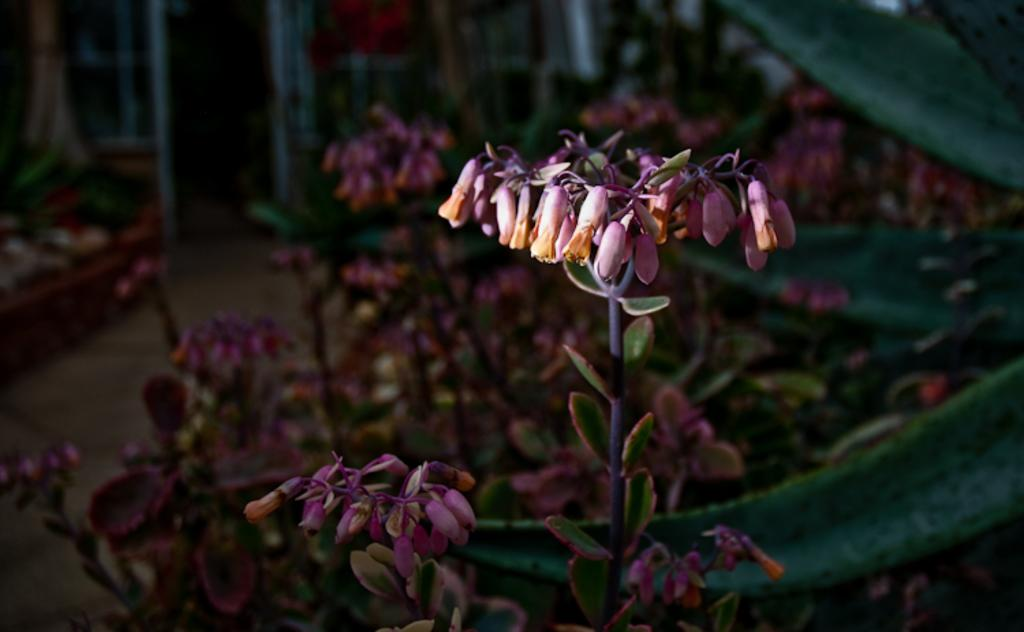What type of flowers can be seen in the image? There are purple flowers in the image. Where are the flowers located? The flowers are on a plant. What is the weather condition in the image? There is bright sunshine falling on one of the plants. How many kittens can be seen playing with the flowers in the image? There are no kittens present in the image. 